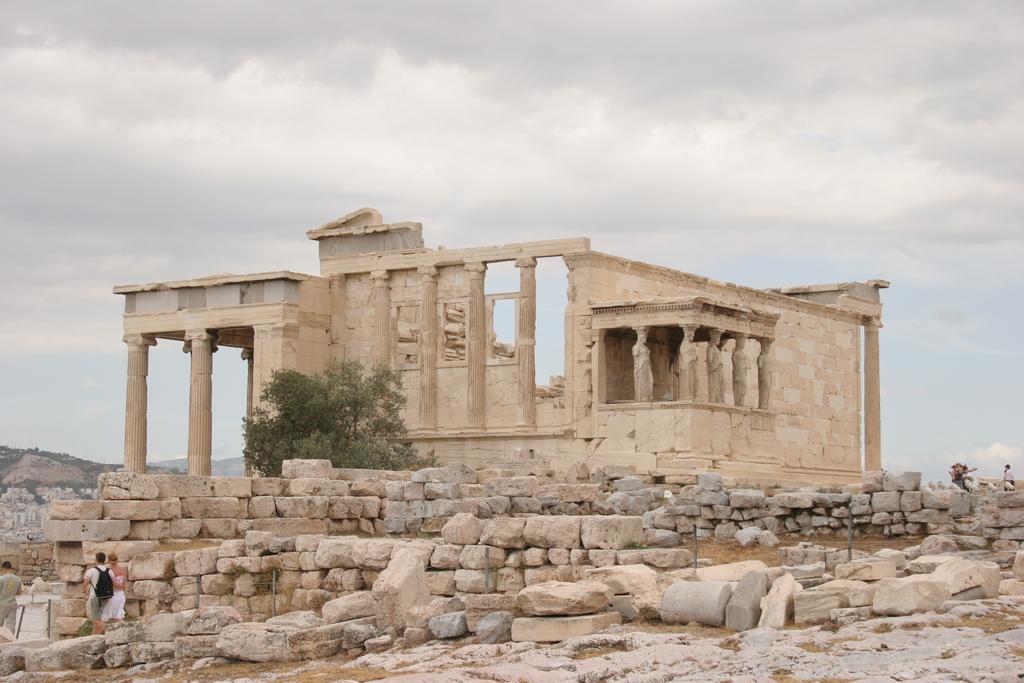Can you describe this image briefly? In this image there are a few people walking and a few people sitting on the rocks, in this image there is a tree and there is an archaeological site. In the background of the image there are mountains and rocks, at the top of the image there are clouds in the sky. 